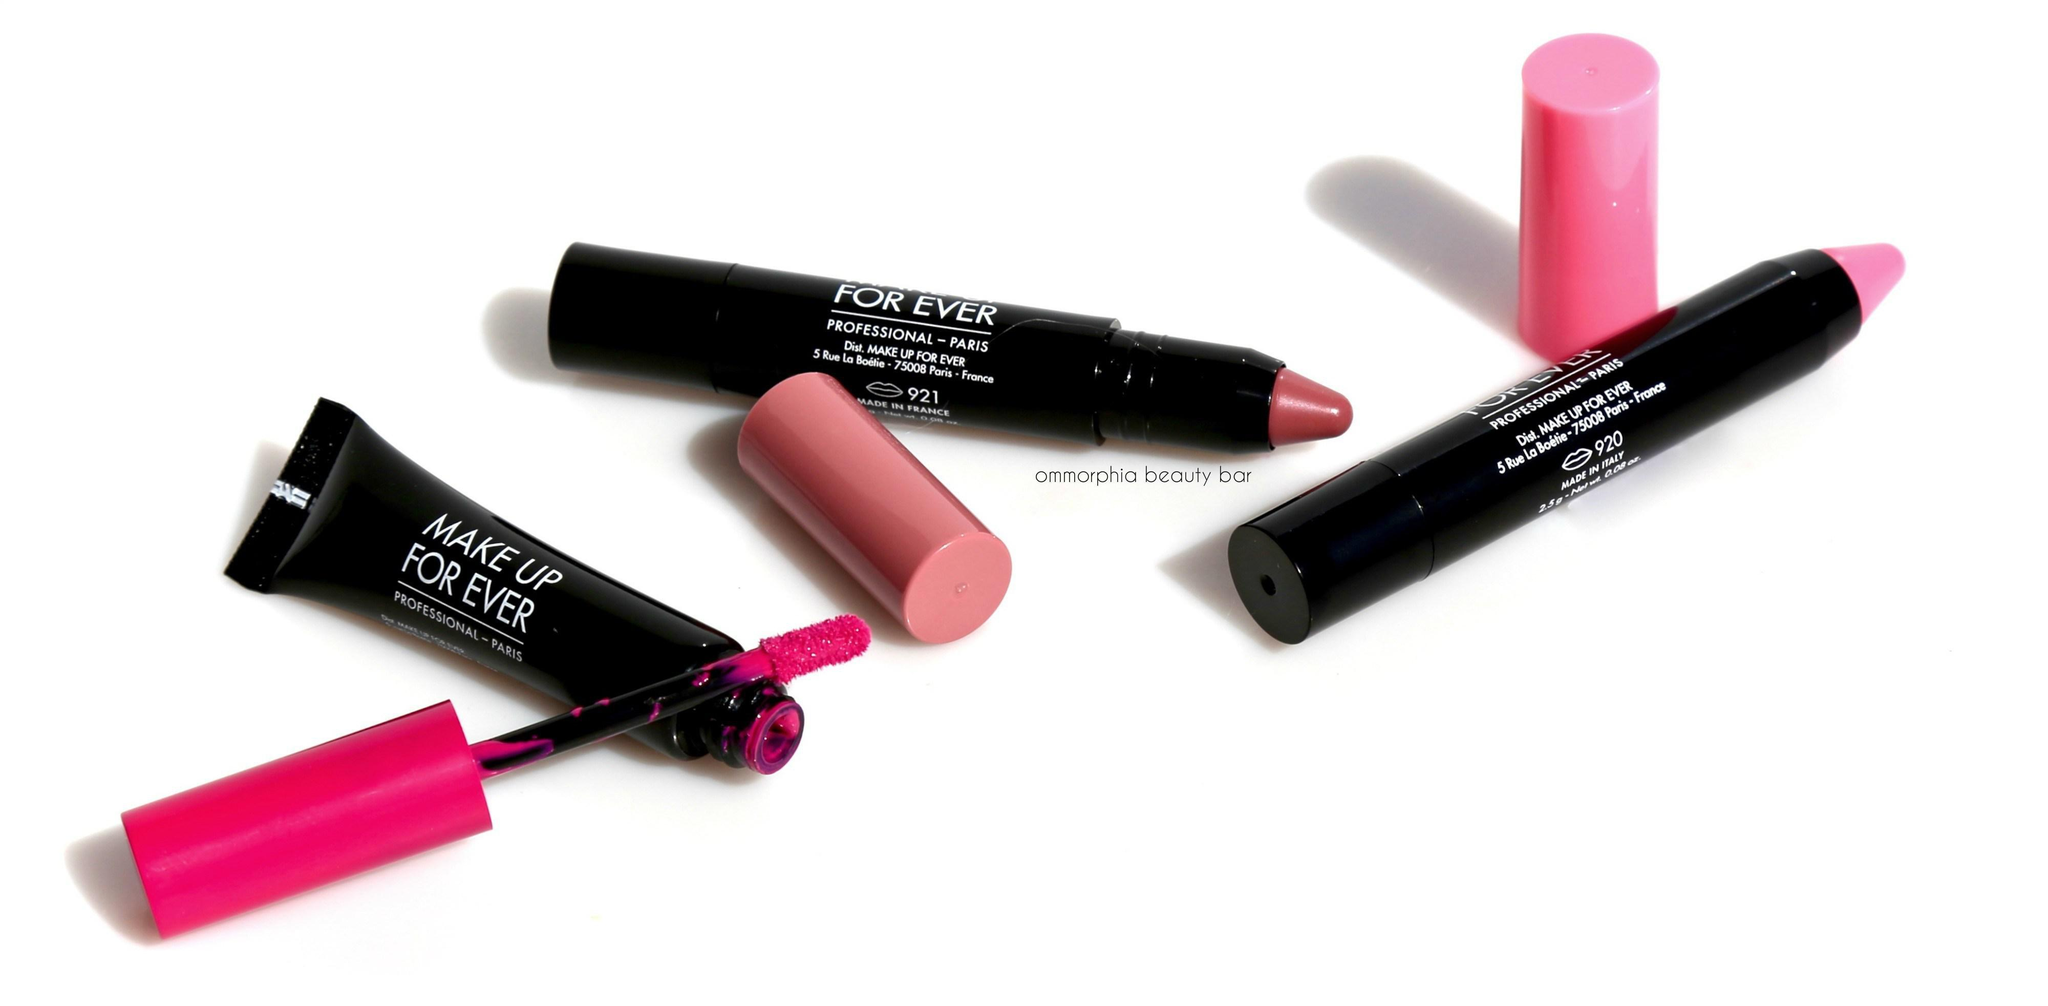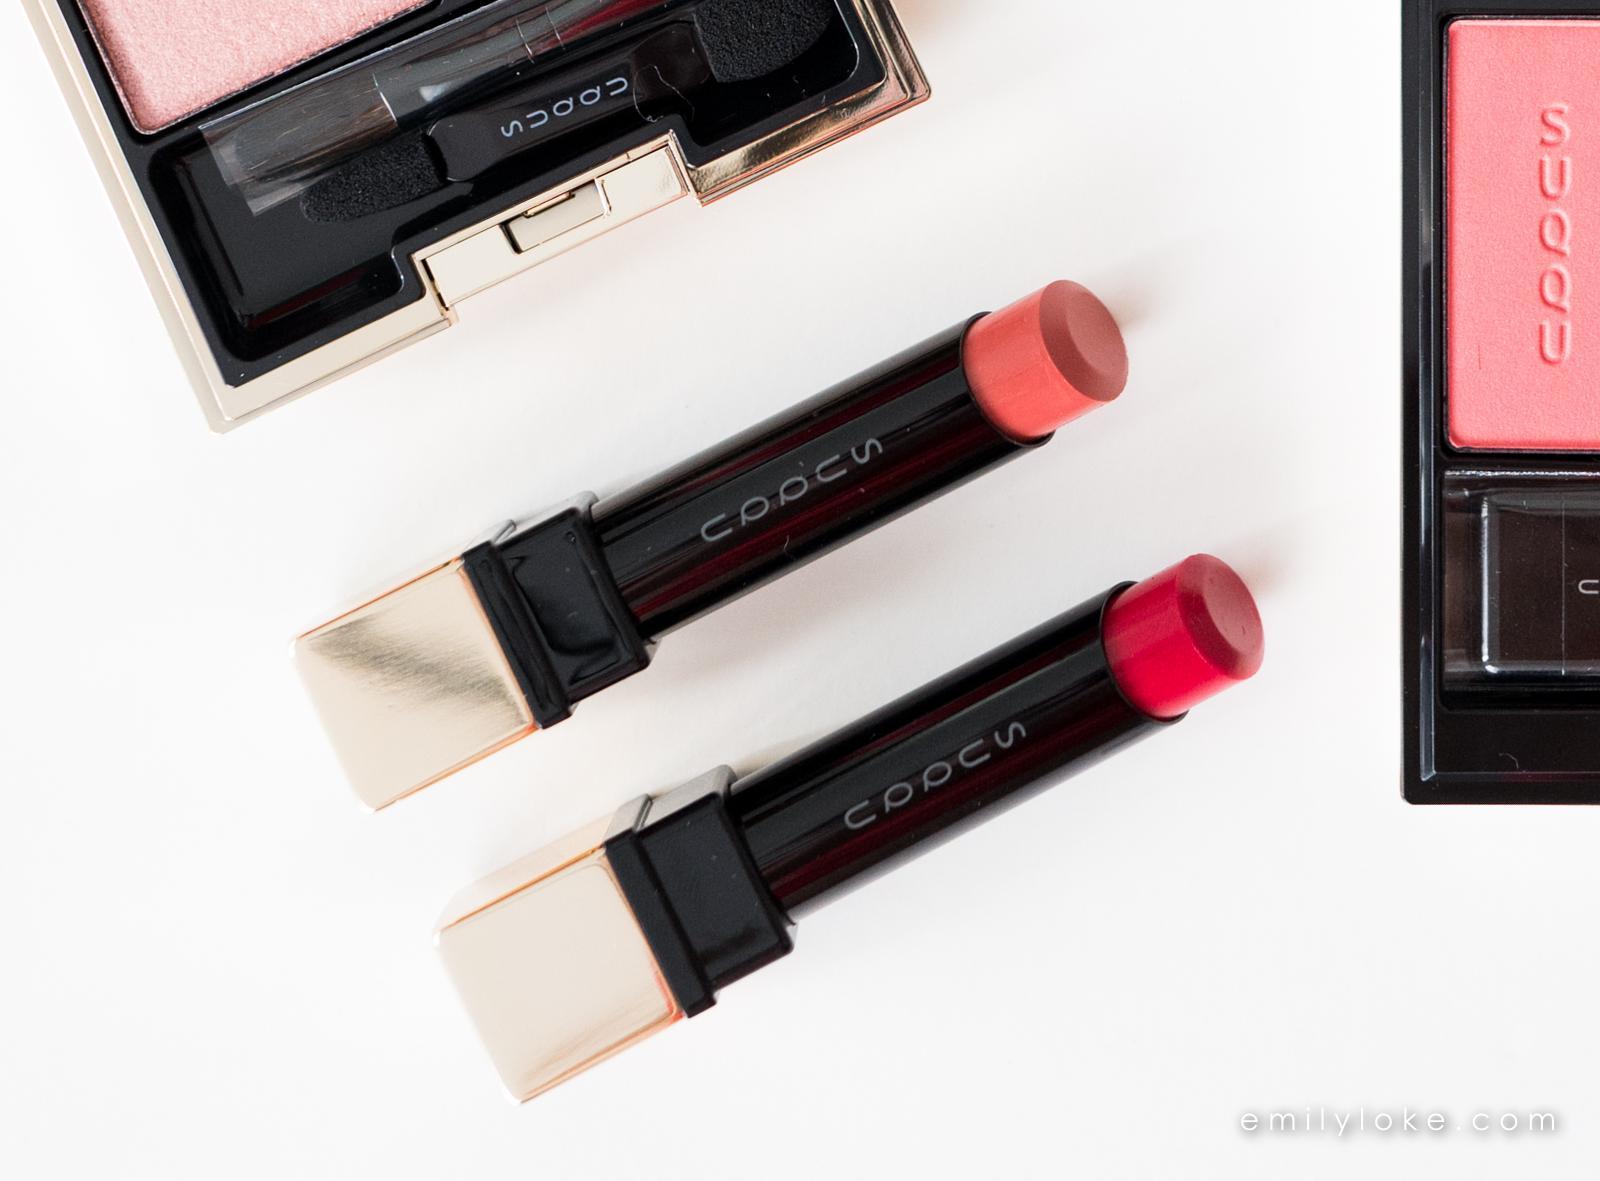The first image is the image on the left, the second image is the image on the right. Considering the images on both sides, is "Each image includes an unlidded double-sided lip makeup with a marker-type tip on each end of a stick." valid? Answer yes or no. No. The first image is the image on the left, the second image is the image on the right. Considering the images on both sides, is "The makeup in the left image is photographed against a pure white background with no decoration on it." valid? Answer yes or no. Yes. 